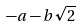Convert formula to latex. <formula><loc_0><loc_0><loc_500><loc_500>- a - b \sqrt { 2 }</formula> 